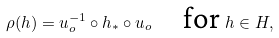Convert formula to latex. <formula><loc_0><loc_0><loc_500><loc_500>\rho ( h ) = u _ { o } ^ { - 1 } \circ h _ { * } \circ u _ { o } \quad \text {for } h \in H ,</formula> 